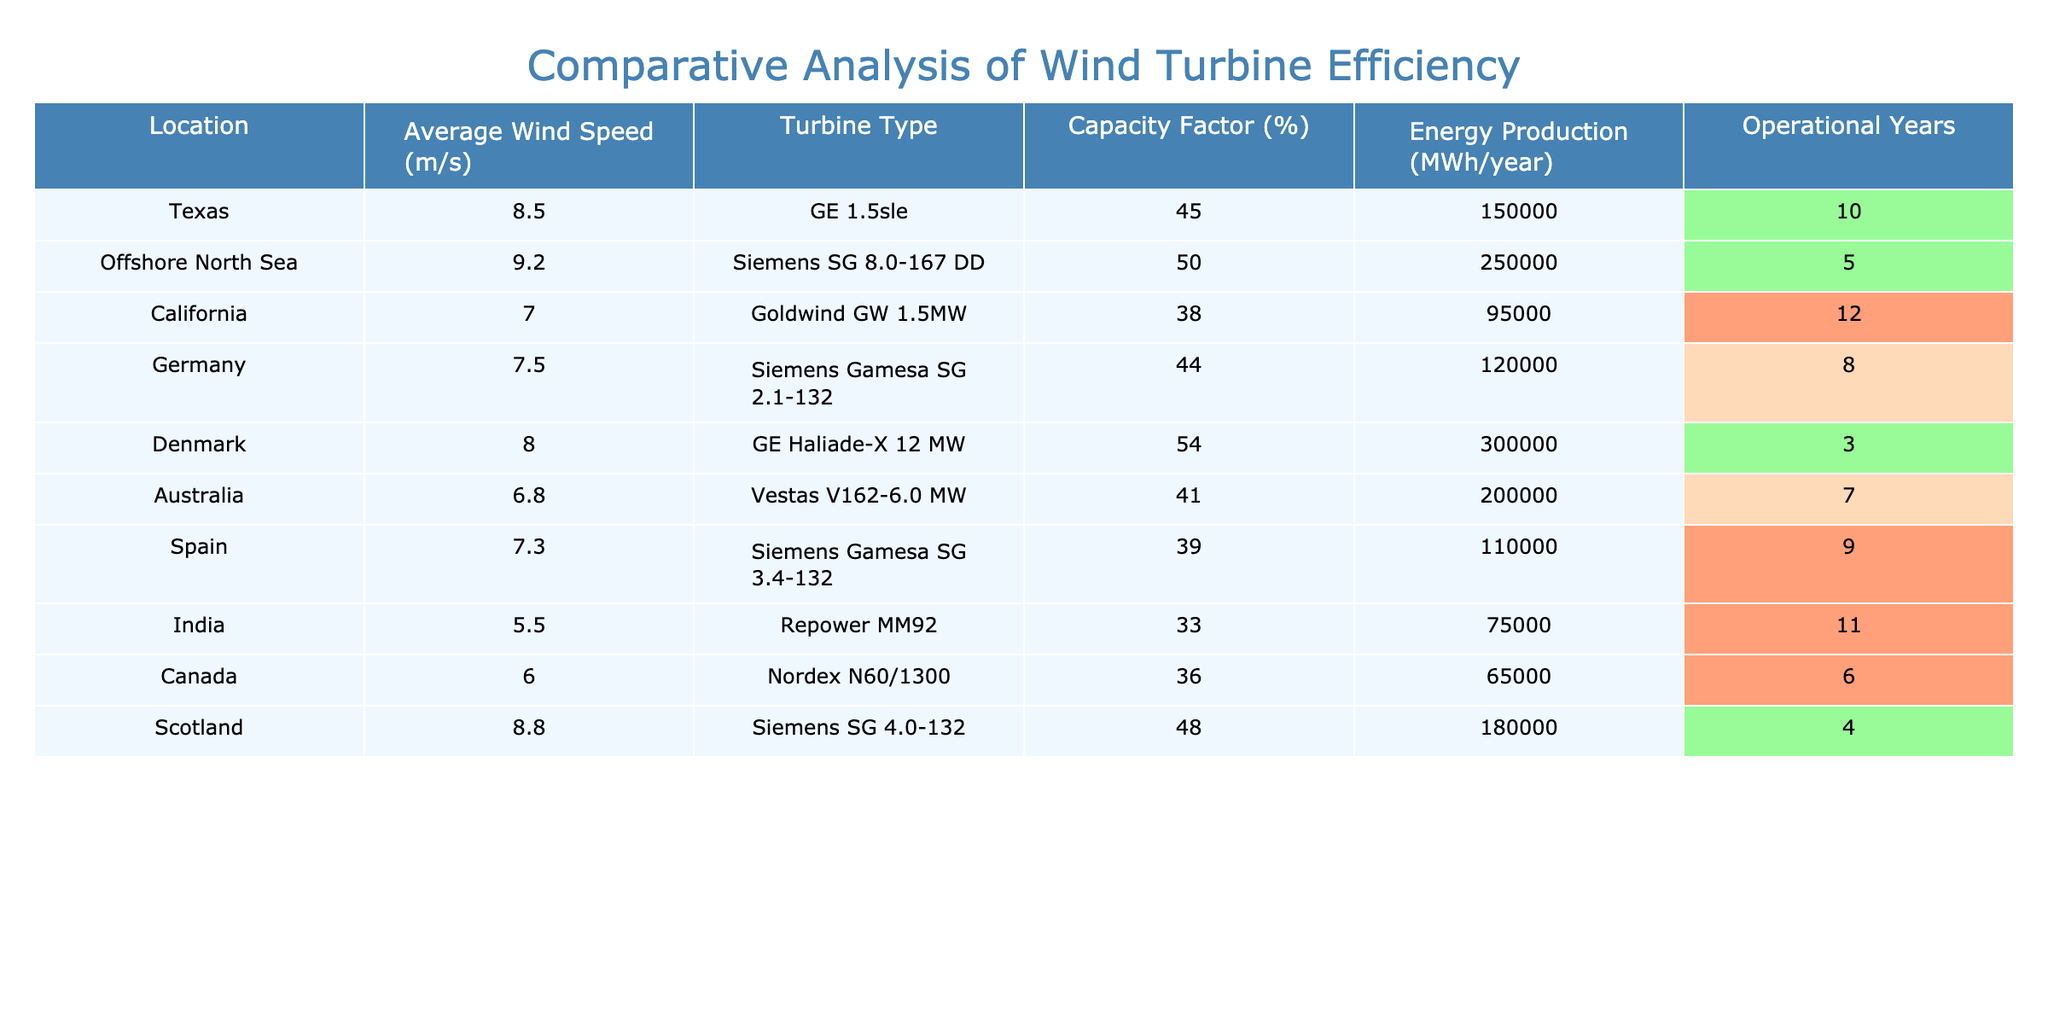What is the average wind speed in Texas? The table shows that the average wind speed in Texas is listed directly as 8.5 m/s under the "Average Wind Speed (m/s)" column.
Answer: 8.5 m/s Which location has the highest capacity factor? By comparing the values under the "Capacity Factor (%)" column, Denmark has the highest value at 54%.
Answer: Denmark What is the energy production in Offshore North Sea? The table states that the energy production in Offshore North Sea is 250,000 MWh/year in the "Energy Production (MWh/year)" column.
Answer: 250,000 MWh/year What is the operational years for the turbine in California? Referring to the "Operational Years" column, California has 12 years listed for its turbine operation.
Answer: 12 years Is the capacity factor for turbines in India greater than 35%? The capacity factor for India is listed as 33%, which is less than 35%. Thus, the statement is false.
Answer: No Calculate the average capacity factor across all locations. The capacity factors are: 45, 50, 38, 44, 54, 41, 39, 33, 36, and 48. Adding these gives a total of 418. Dividing by 10 (the number of locations) results in an average of 41.8%.
Answer: 41.8% Which turbine type is associated with the second highest energy production? The turbine in Offshore North Sea (Siemens SG 8.0-167 DD) has the highest energy production at 250,000 MWh/year, followed by the turbine in Denmark (GE Haliade-X 12 MW) with 300,000 MWh/year. Thus, the second highest is by Denmark's turbine.
Answer: Siemens SG 8.0-167 DD What percentage of locations have a capacity factor below 40%? The locations with a capacity factor below 40% are California (38%), India (33%), and Spain (39%), which are 3 out of 10 total locations. Therefore, the percentage is (3/10)*100 = 30%.
Answer: 30% Which location has the lowest average wind speed, and what is that speed? The location with the lowest average wind speed is India, showing 5.5 m/s in the table under "Average Wind Speed (m/s)".
Answer: India, 5.5 m/s What is the difference in energy production between Texas and Australia? The energy production in Texas is 150,000 MWh/year, while for Australia it is 200,000 MWh/year. The difference is 200,000 - 150,000 = 50,000 MWh/year.
Answer: 50,000 MWh/year 